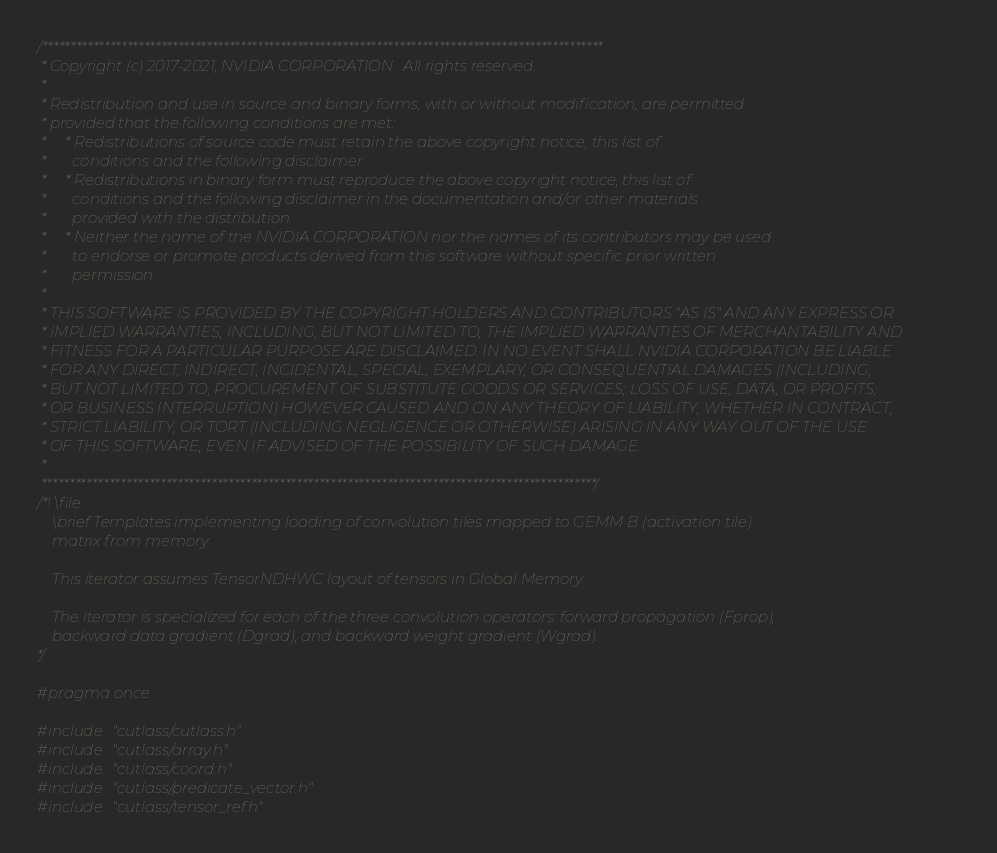<code> <loc_0><loc_0><loc_500><loc_500><_C_>/***************************************************************************************************
 * Copyright (c) 2017-2021, NVIDIA CORPORATION.  All rights reserved.
 *
 * Redistribution and use in source and binary forms, with or without modification, are permitted
 * provided that the following conditions are met:
 *     * Redistributions of source code must retain the above copyright notice, this list of
 *       conditions and the following disclaimer.
 *     * Redistributions in binary form must reproduce the above copyright notice, this list of
 *       conditions and the following disclaimer in the documentation and/or other materials
 *       provided with the distribution.
 *     * Neither the name of the NVIDIA CORPORATION nor the names of its contributors may be used
 *       to endorse or promote products derived from this software without specific prior written
 *       permission.
 *
 * THIS SOFTWARE IS PROVIDED BY THE COPYRIGHT HOLDERS AND CONTRIBUTORS "AS IS" AND ANY EXPRESS OR
 * IMPLIED WARRANTIES, INCLUDING, BUT NOT LIMITED TO, THE IMPLIED WARRANTIES OF MERCHANTABILITY AND
 * FITNESS FOR A PARTICULAR PURPOSE ARE DISCLAIMED. IN NO EVENT SHALL NVIDIA CORPORATION BE LIABLE
 * FOR ANY DIRECT, INDIRECT, INCIDENTAL, SPECIAL, EXEMPLARY, OR CONSEQUENTIAL DAMAGES (INCLUDING,
 * BUT NOT LIMITED TO, PROCUREMENT OF SUBSTITUTE GOODS OR SERVICES; LOSS OF USE, DATA, OR PROFITS;
 * OR BUSINESS INTERRUPTION) HOWEVER CAUSED AND ON ANY THEORY OF LIABILITY, WHETHER IN CONTRACT,
 * STRICT LIABILITY, OR TORT (INCLUDING NEGLIGENCE OR OTHERWISE) ARISING IN ANY WAY OUT OF THE USE
 * OF THIS SOFTWARE, EVEN IF ADVISED OF THE POSSIBILITY OF SUCH DAMAGE.
 *
 **************************************************************************************************/
/*! \file
    \brief Templates implementing loading of convolution tiles mapped to GEMM B (activation tile) 
    matrix from memory.

    This iterator assumes TensorNDHWC layout of tensors in Global Memory.

    The iterator is specialized for each of the three convolution operators: forward propagation (Fprop),
    backward data gradient (Dgrad), and backward weight gradient (Wgrad).
*/

#pragma once

#include "cutlass/cutlass.h"
#include "cutlass/array.h"
#include "cutlass/coord.h"
#include "cutlass/predicate_vector.h"
#include "cutlass/tensor_ref.h"</code> 